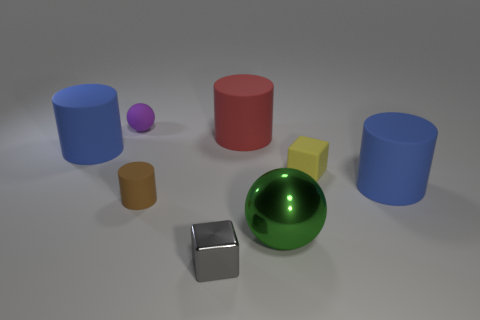Subtract all gray cylinders. Subtract all green balls. How many cylinders are left? 4 Add 1 small brown metallic blocks. How many objects exist? 9 Subtract all blocks. How many objects are left? 6 Add 4 large blue matte objects. How many large blue matte objects are left? 6 Add 7 small gray objects. How many small gray objects exist? 8 Subtract 0 gray spheres. How many objects are left? 8 Subtract all big red metal cylinders. Subtract all tiny yellow matte objects. How many objects are left? 7 